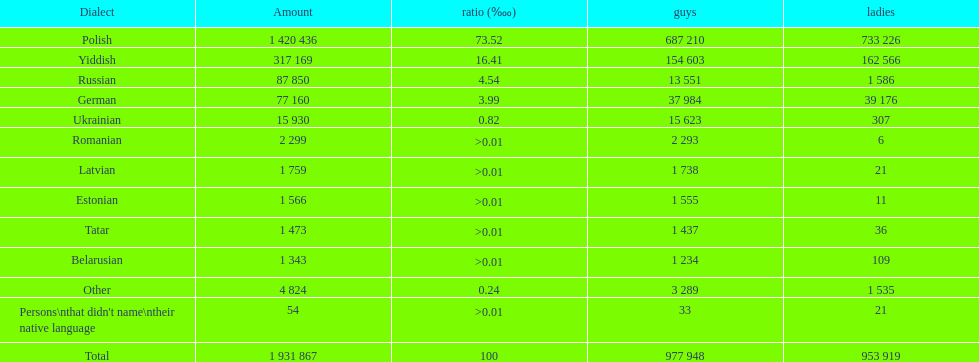What is the highest percentage of speakers other than polish? Yiddish. 